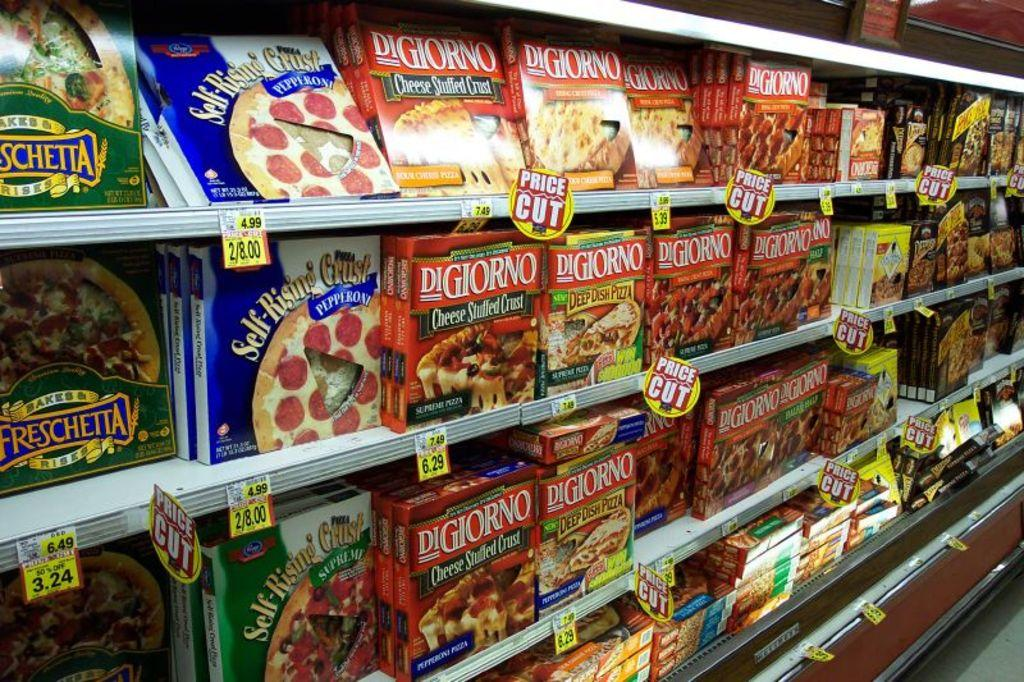<image>
Summarize the visual content of the image. The pizza section of this grocery market is loaded with tons of options like Freschetts, Digiornos, and many others. 